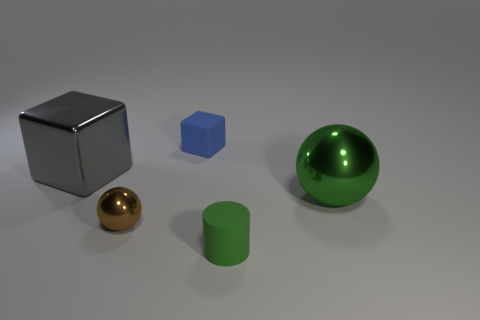Add 3 cyan matte objects. How many objects exist? 8 Subtract all spheres. How many objects are left? 3 Add 4 gray things. How many gray things are left? 5 Add 1 small cyan metallic cubes. How many small cyan metallic cubes exist? 1 Subtract 0 yellow blocks. How many objects are left? 5 Subtract all small things. Subtract all tiny rubber objects. How many objects are left? 0 